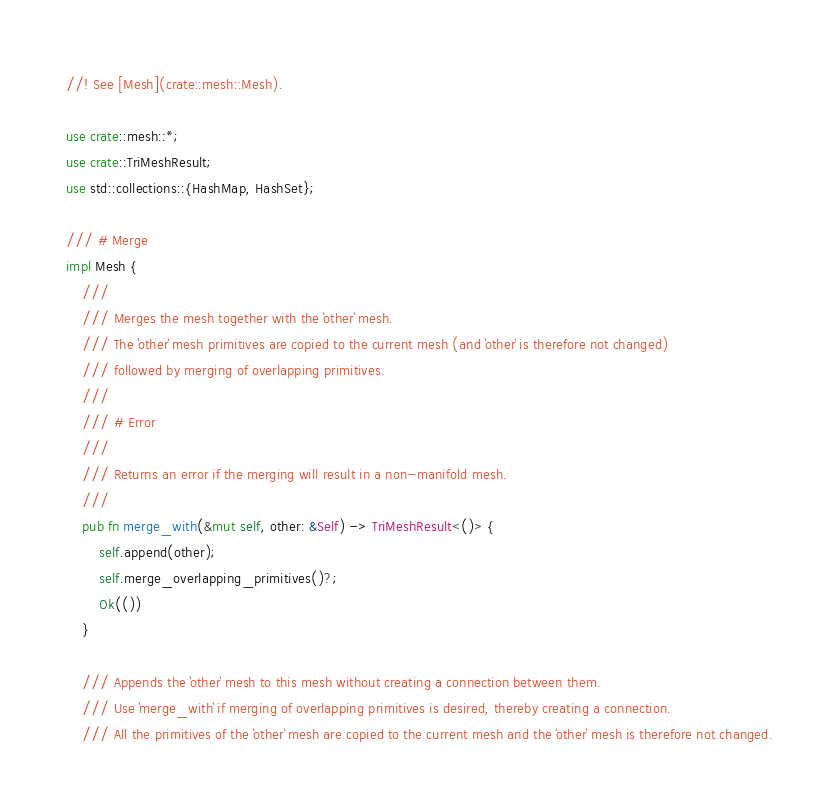<code> <loc_0><loc_0><loc_500><loc_500><_Rust_>//! See [Mesh](crate::mesh::Mesh).

use crate::mesh::*;
use crate::TriMeshResult;
use std::collections::{HashMap, HashSet};

/// # Merge
impl Mesh {
    ///
    /// Merges the mesh together with the `other` mesh.
    /// The `other` mesh primitives are copied to the current mesh (and `other` is therefore not changed)
    /// followed by merging of overlapping primitives.
    ///
    /// # Error
    ///
    /// Returns an error if the merging will result in a non-manifold mesh.
    ///
    pub fn merge_with(&mut self, other: &Self) -> TriMeshResult<()> {
        self.append(other);
        self.merge_overlapping_primitives()?;
        Ok(())
    }

    /// Appends the `other` mesh to this mesh without creating a connection between them.
    /// Use `merge_with` if merging of overlapping primitives is desired, thereby creating a connection.
    /// All the primitives of the `other` mesh are copied to the current mesh and the `other` mesh is therefore not changed.</code> 